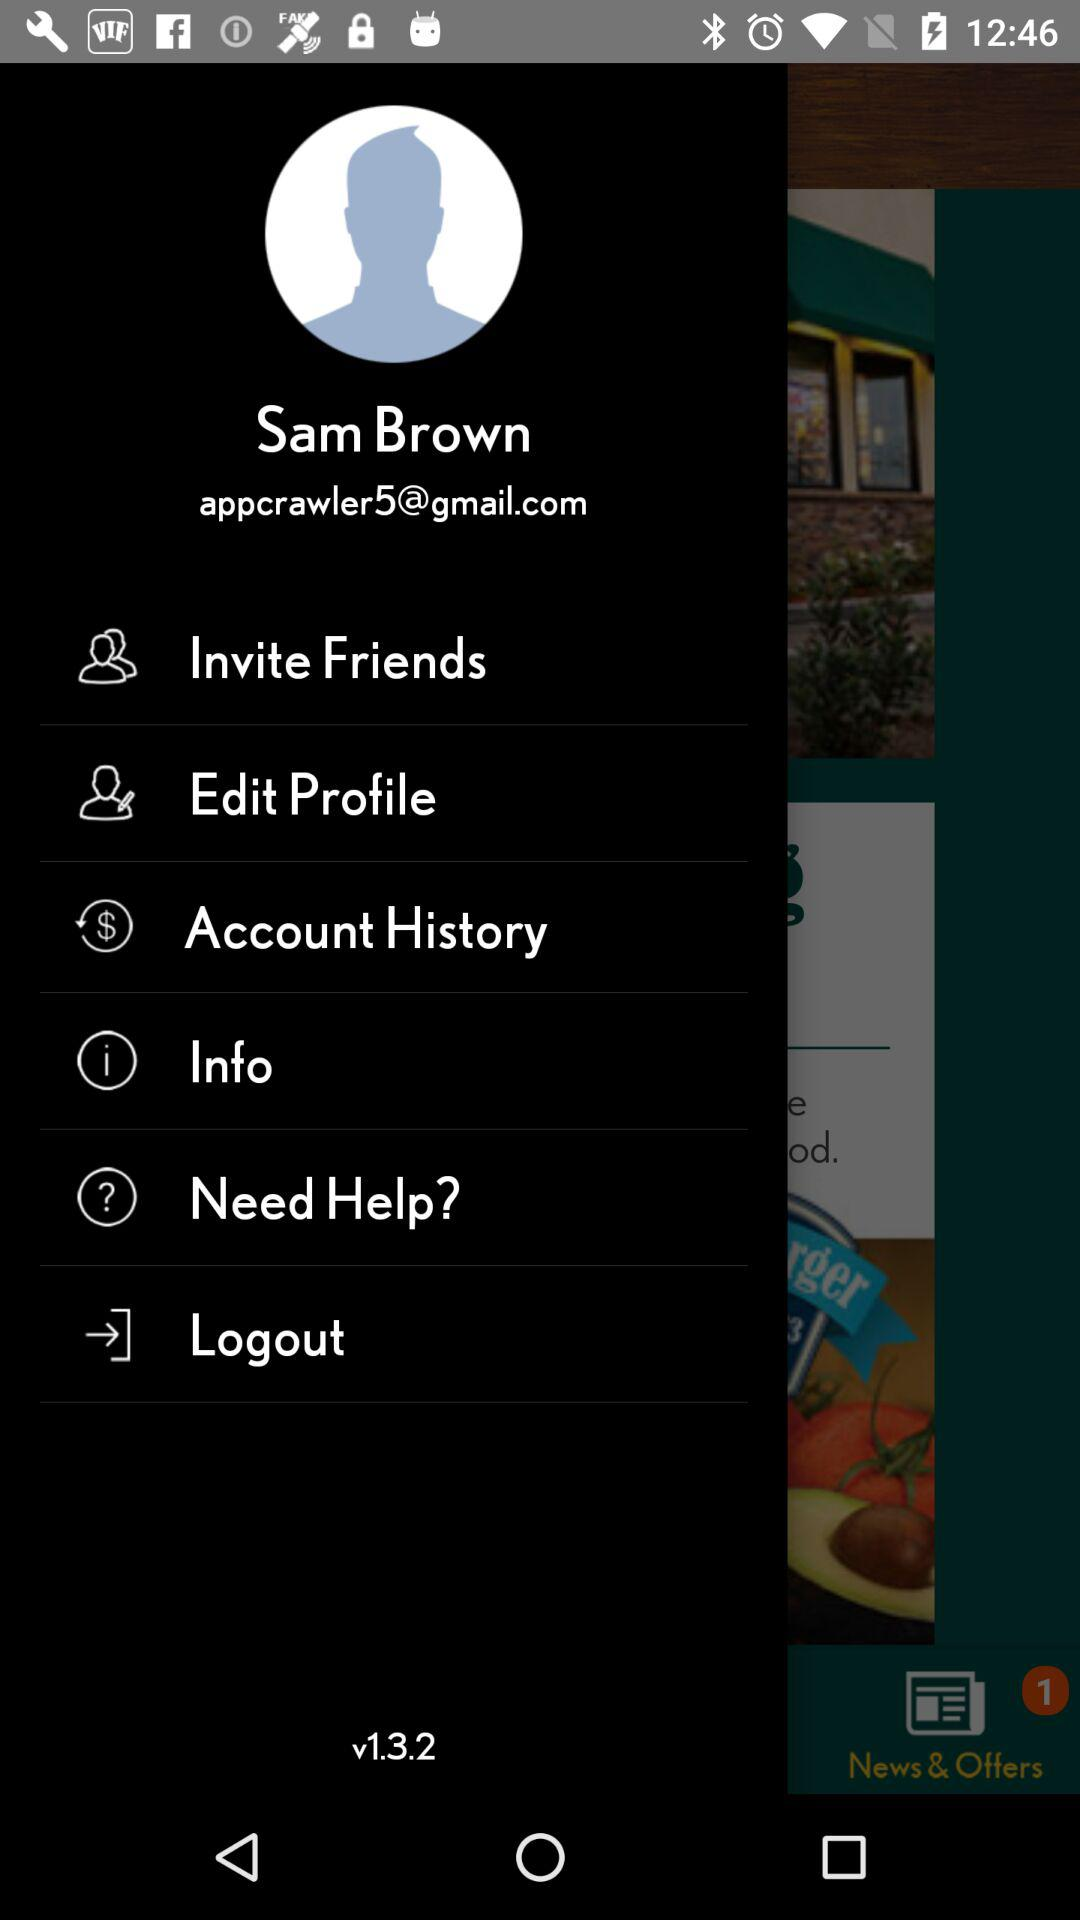What is the name of the user? The name of the user is Sam Brown. 